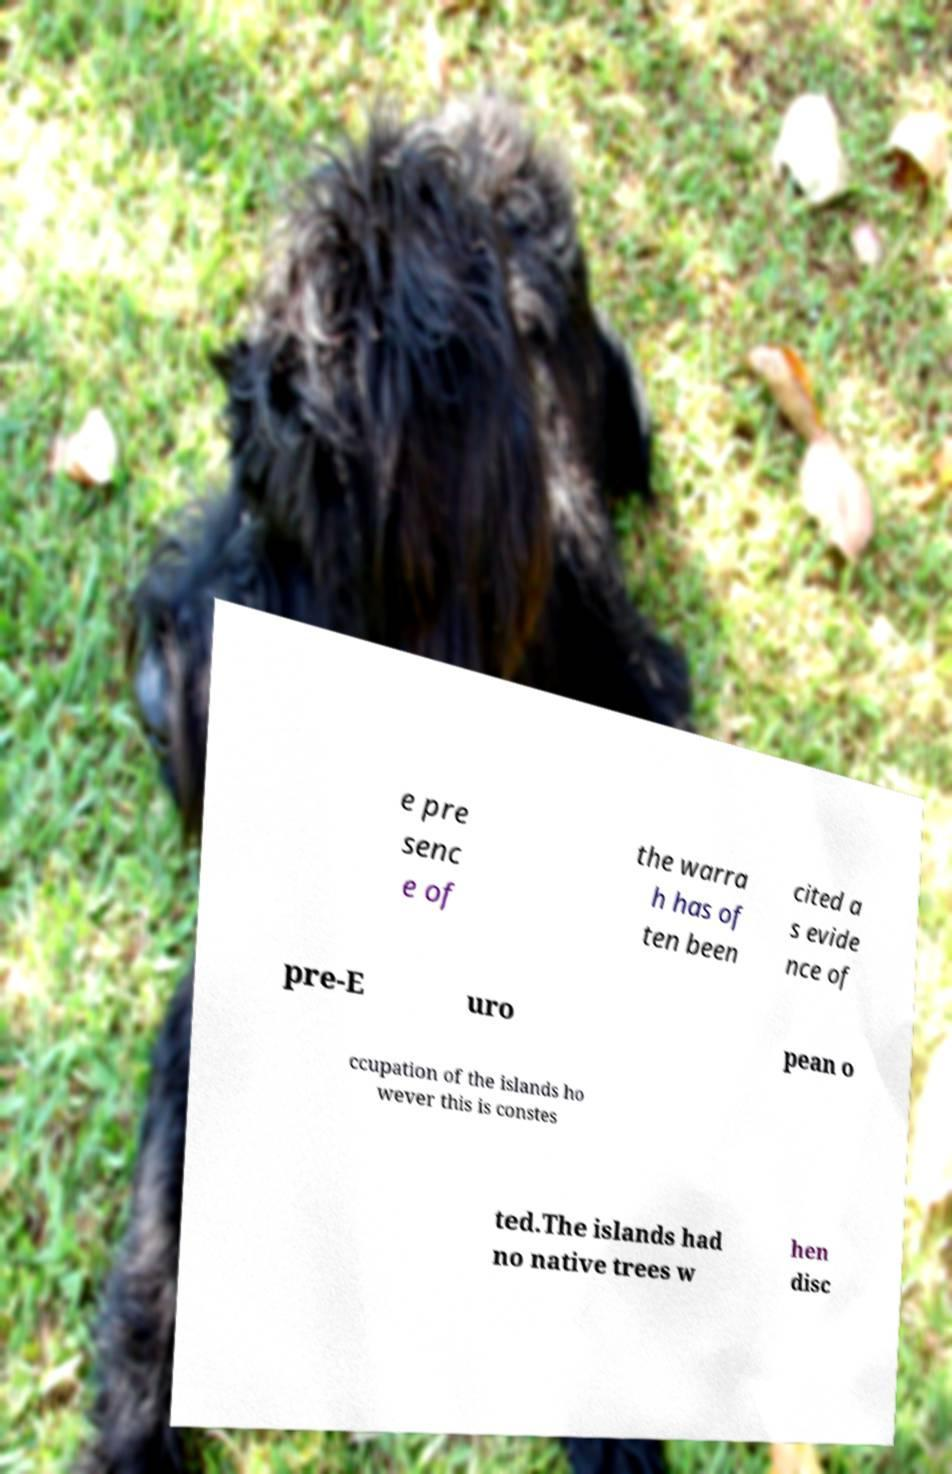For documentation purposes, I need the text within this image transcribed. Could you provide that? e pre senc e of the warra h has of ten been cited a s evide nce of pre-E uro pean o ccupation of the islands ho wever this is constes ted.The islands had no native trees w hen disc 